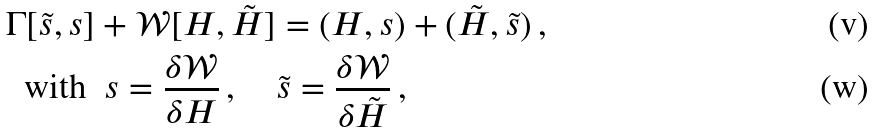<formula> <loc_0><loc_0><loc_500><loc_500>\Gamma [ \tilde { s } , s ] & + \mathcal { W } [ H , \tilde { H } ] = ( H , s ) + ( \tilde { H } , \tilde { s } ) \, , \\ \text {with} \ & \ s = \frac { \delta \mathcal { W } } { \delta H } \, , \quad \tilde { s } = \frac { \delta \mathcal { W } } { \delta \tilde { H } } \, ,</formula> 